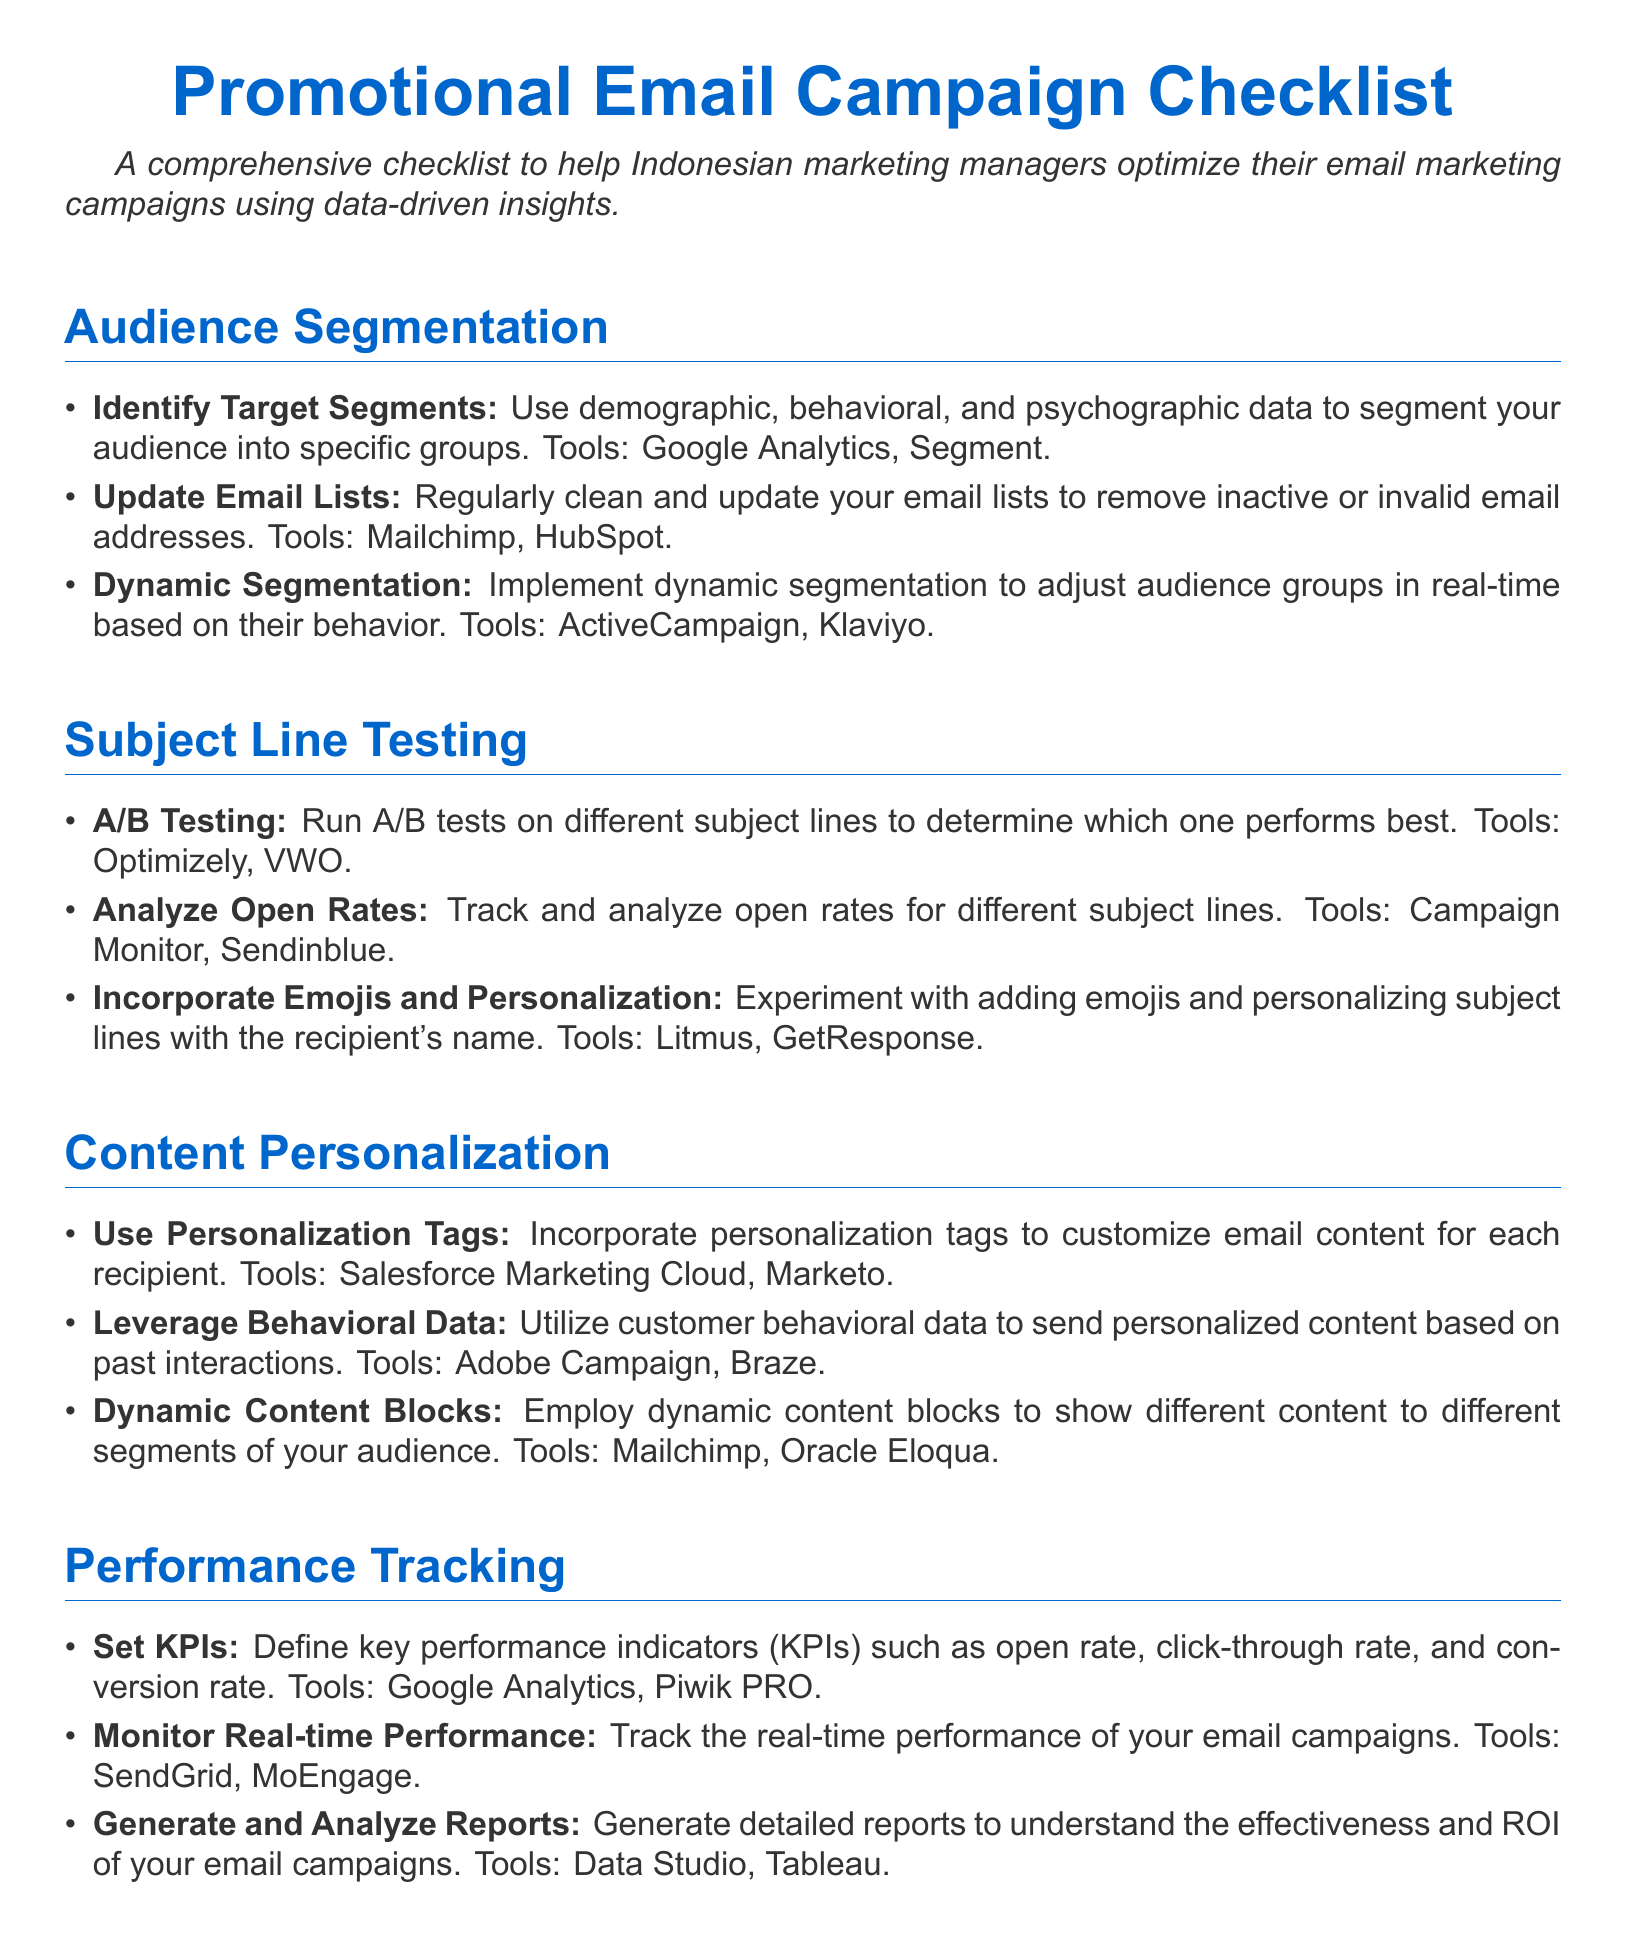what is the primary purpose of the checklist? The checklist aims to help Indonesian marketing managers optimize their email marketing campaigns using data-driven insights.
Answer: optimize email marketing campaigns how many sections are in the checklist? The checklist contains four sections: Audience Segmentation, Subject Line Testing, Content Personalization, and Performance Tracking.
Answer: four which tool is suggested for dynamic email segmentation? The document mentions ActiveCampaign and Klaviyo as tools for dynamic segmentation.
Answer: ActiveCampaign, Klaviyo what KPI is mentioned for performance tracking? The checklist highlights open rate, click-through rate, and conversion rate as key performance indicators.
Answer: open rate, click-through rate, conversion rate what type of testing is recommended for subject lines? The document recommends A/B testing for subject lines to determine performance.
Answer: A/B testing name one tool used for analyzing open rates. Campaign Monitor and Sendinblue are mentioned as tools for analyzing open rates.
Answer: Campaign Monitor which section addresses the use of personalization tags? The use of personalization tags is addressed in the Content Personalization section.
Answer: Content Personalization how often should email lists be updated? The document suggests regularly cleaning and updating email lists.
Answer: regularly 